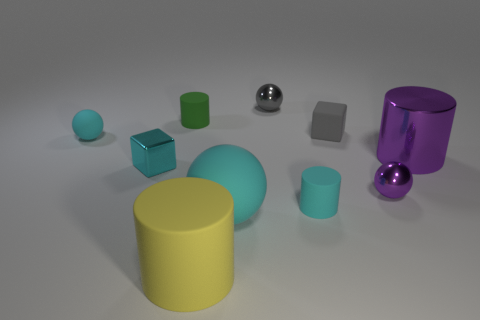What number of cyan balls have the same size as the yellow rubber thing?
Offer a very short reply. 1. What material is the tiny purple thing that is the same shape as the tiny gray metal thing?
Give a very brief answer. Metal. What number of things are either tiny shiny objects on the left side of the green rubber cylinder or spheres right of the yellow matte cylinder?
Provide a succinct answer. 4. Do the green object and the cyan rubber object that is behind the big shiny object have the same shape?
Your answer should be compact. No. What shape is the cyan matte thing that is behind the small cyan rubber thing that is right of the tiny matte cylinder behind the tiny cyan metallic cube?
Provide a short and direct response. Sphere. How many other things are there of the same material as the big yellow cylinder?
Your response must be concise. 5. What number of things are rubber cylinders on the left side of the large sphere or tiny green matte things?
Give a very brief answer. 2. There is a big object that is to the left of the matte sphere to the right of the green object; what shape is it?
Offer a terse response. Cylinder. Is the shape of the tiny cyan object that is behind the big purple metal object the same as  the large yellow thing?
Provide a succinct answer. No. There is a sphere to the right of the gray metal ball; what is its color?
Keep it short and to the point. Purple. 